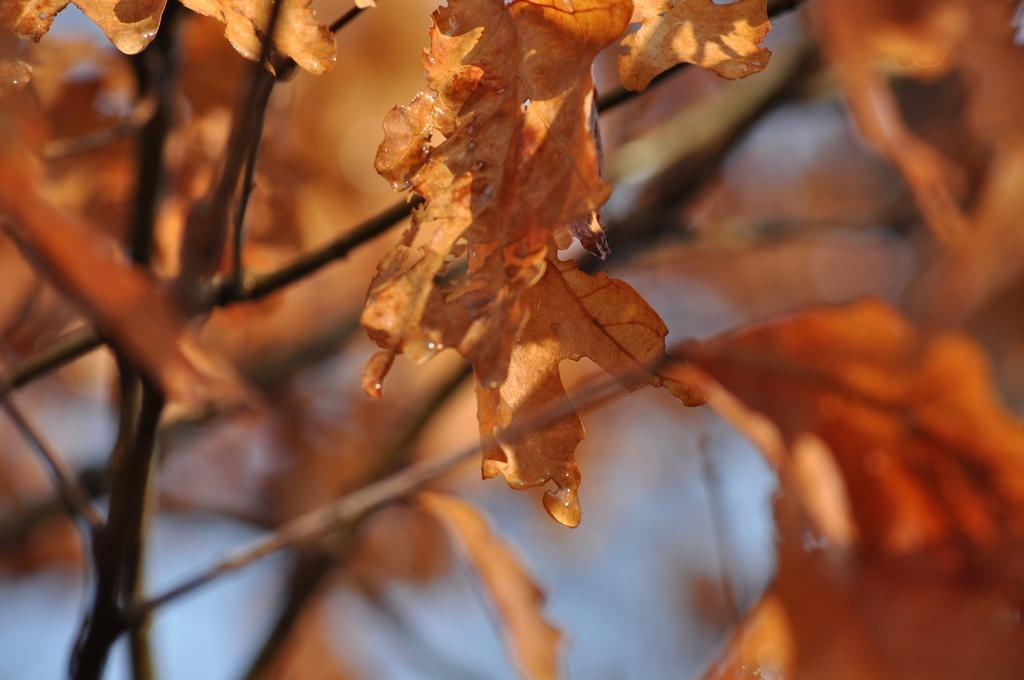What type of plant parts can be seen in the image? There are leaves and stems in the image. Can you describe the background of the image? The background of the image is blurred. Reasoning: Let's think step by step by step in order to produce the conversation. We start by identifying the main subjects in the image, which are the leaves and stems. Then, we describe the background of the image, which is blurred. Each question is designed to elicit a specific detail about the image that is known from the provided facts. Absurd Question/Answer: How do the leaves roll in the image? The leaves do not roll in the image; they are stationary. How do the leaves jump in the image? The leaves do not jump in the image; they are stationary. 